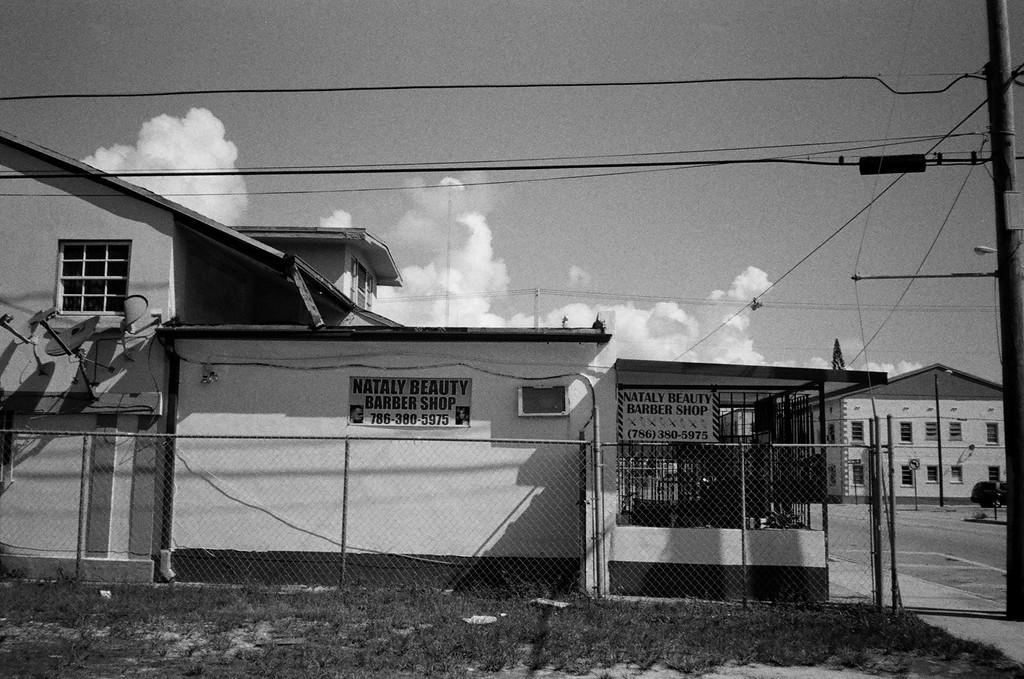Could you give a brief overview of what you see in this image? This is a black and white image. We can see some houses and poles with wires. There are a few boards with text. We can also see some objects attached to the wall of one of the houses. We can see the fence and the ground with some objects. We can see some grass and plants. We can also see the sky with clouds. 